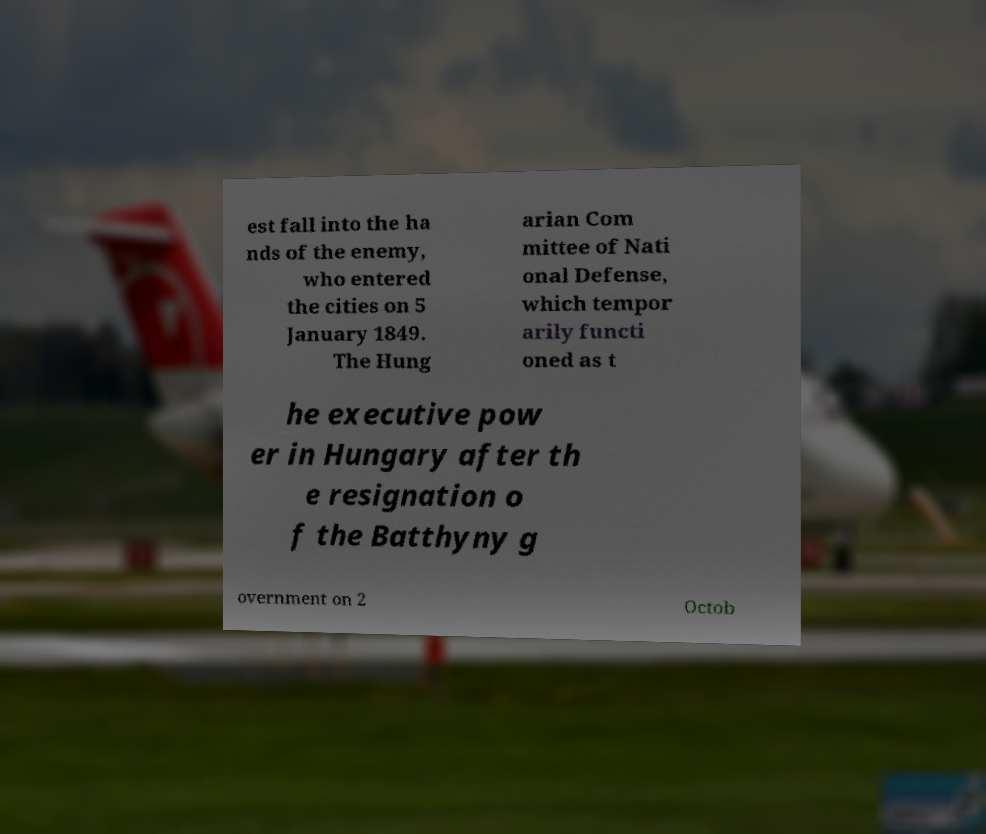Can you accurately transcribe the text from the provided image for me? est fall into the ha nds of the enemy, who entered the cities on 5 January 1849. The Hung arian Com mittee of Nati onal Defense, which tempor arily functi oned as t he executive pow er in Hungary after th e resignation o f the Batthyny g overnment on 2 Octob 